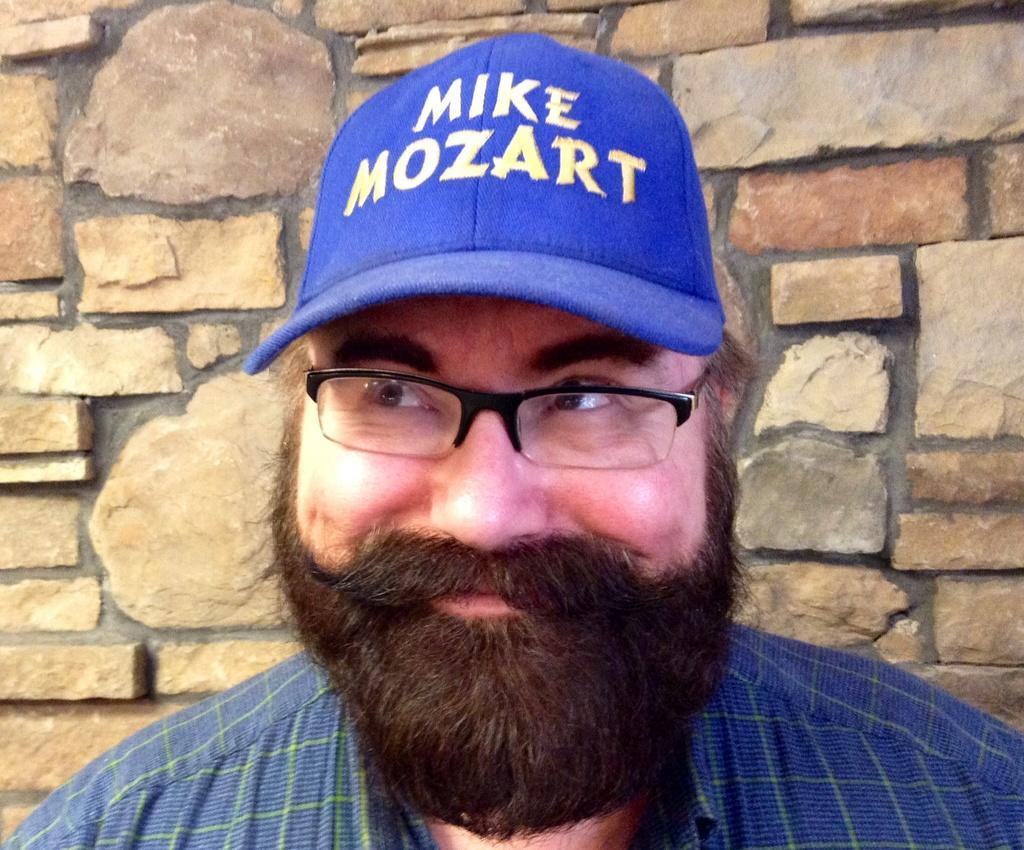How would you summarize this image in a sentence or two? In this picture there is a man who is wearing cap, spectacle and shirt. He is smiling and standing near to the wall. 